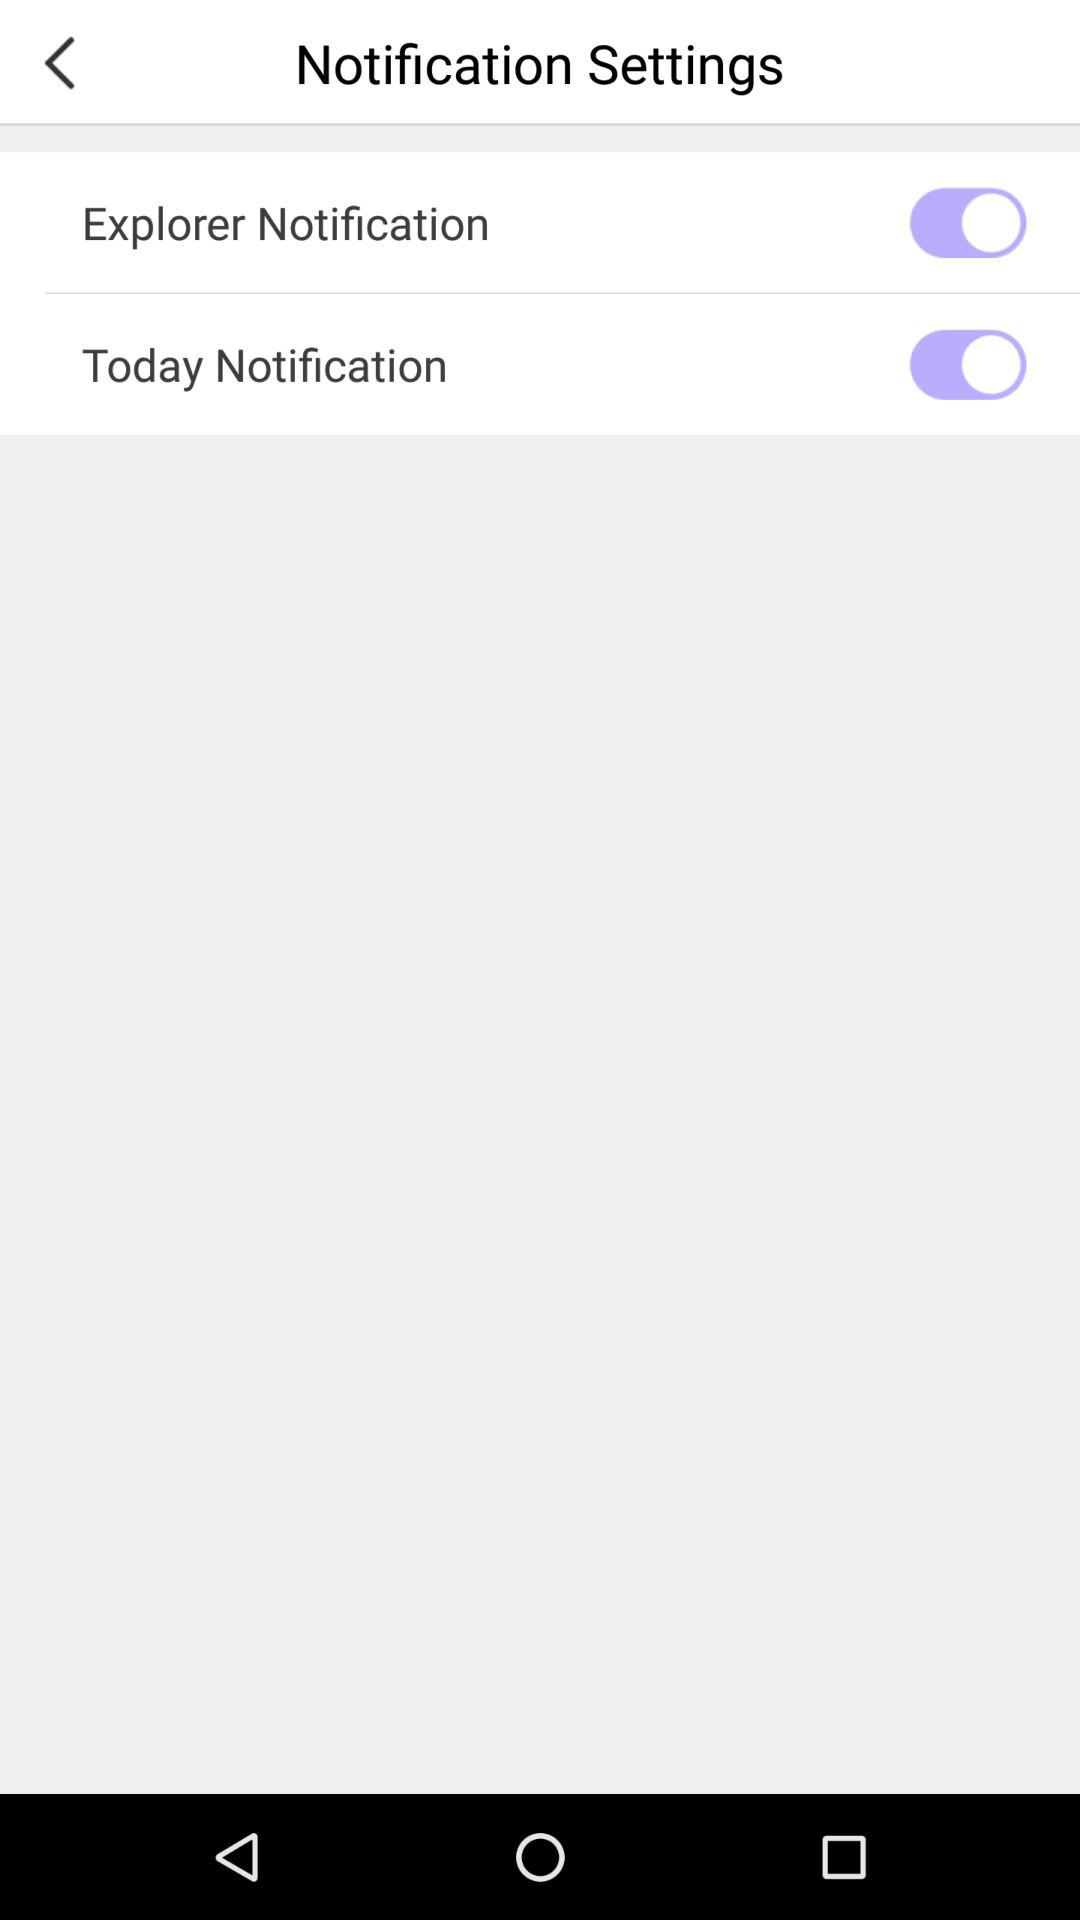What is the status of "Today Notification"? The status is "on". 